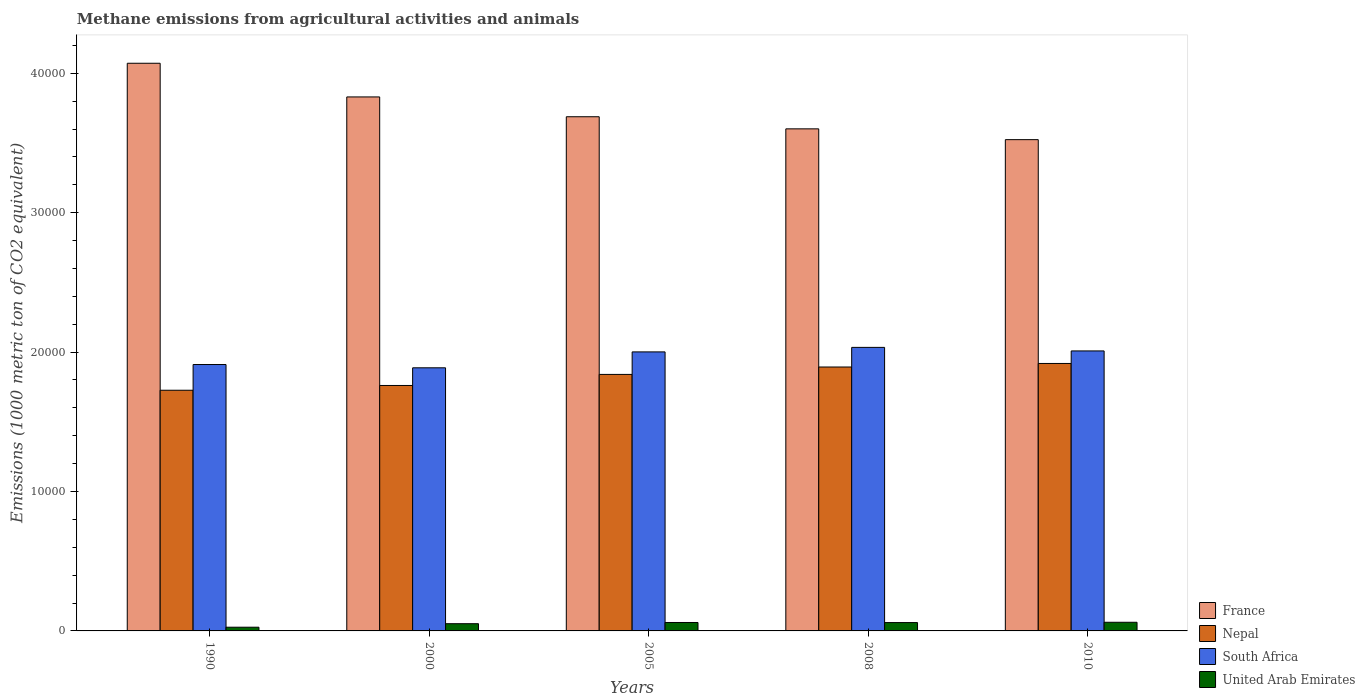How many different coloured bars are there?
Make the answer very short. 4. How many groups of bars are there?
Keep it short and to the point. 5. Are the number of bars per tick equal to the number of legend labels?
Ensure brevity in your answer.  Yes. Are the number of bars on each tick of the X-axis equal?
Provide a short and direct response. Yes. How many bars are there on the 4th tick from the left?
Your answer should be compact. 4. How many bars are there on the 4th tick from the right?
Your response must be concise. 4. What is the label of the 3rd group of bars from the left?
Keep it short and to the point. 2005. What is the amount of methane emitted in South Africa in 2008?
Ensure brevity in your answer.  2.03e+04. Across all years, what is the maximum amount of methane emitted in Nepal?
Make the answer very short. 1.92e+04. Across all years, what is the minimum amount of methane emitted in United Arab Emirates?
Your answer should be very brief. 266.3. In which year was the amount of methane emitted in United Arab Emirates maximum?
Offer a terse response. 2010. In which year was the amount of methane emitted in South Africa minimum?
Provide a succinct answer. 2000. What is the total amount of methane emitted in France in the graph?
Keep it short and to the point. 1.87e+05. What is the difference between the amount of methane emitted in South Africa in 2000 and that in 2010?
Keep it short and to the point. -1210. What is the difference between the amount of methane emitted in Nepal in 2008 and the amount of methane emitted in United Arab Emirates in 2000?
Offer a very short reply. 1.84e+04. What is the average amount of methane emitted in South Africa per year?
Offer a very short reply. 1.97e+04. In the year 2008, what is the difference between the amount of methane emitted in Nepal and amount of methane emitted in United Arab Emirates?
Make the answer very short. 1.83e+04. What is the ratio of the amount of methane emitted in Nepal in 1990 to that in 2000?
Provide a succinct answer. 0.98. What is the difference between the highest and the second highest amount of methane emitted in Nepal?
Make the answer very short. 254.4. What is the difference between the highest and the lowest amount of methane emitted in Nepal?
Provide a succinct answer. 1920.6. In how many years, is the amount of methane emitted in South Africa greater than the average amount of methane emitted in South Africa taken over all years?
Your answer should be very brief. 3. Is it the case that in every year, the sum of the amount of methane emitted in United Arab Emirates and amount of methane emitted in Nepal is greater than the sum of amount of methane emitted in South Africa and amount of methane emitted in France?
Make the answer very short. Yes. What does the 3rd bar from the left in 2005 represents?
Your answer should be compact. South Africa. What does the 3rd bar from the right in 2005 represents?
Offer a terse response. Nepal. Is it the case that in every year, the sum of the amount of methane emitted in United Arab Emirates and amount of methane emitted in South Africa is greater than the amount of methane emitted in Nepal?
Make the answer very short. Yes. How many bars are there?
Your answer should be compact. 20. Are all the bars in the graph horizontal?
Ensure brevity in your answer.  No. What is the difference between two consecutive major ticks on the Y-axis?
Your response must be concise. 10000. Does the graph contain any zero values?
Your answer should be compact. No. Does the graph contain grids?
Ensure brevity in your answer.  No. What is the title of the graph?
Offer a terse response. Methane emissions from agricultural activities and animals. Does "Serbia" appear as one of the legend labels in the graph?
Give a very brief answer. No. What is the label or title of the X-axis?
Ensure brevity in your answer.  Years. What is the label or title of the Y-axis?
Provide a short and direct response. Emissions (1000 metric ton of CO2 equivalent). What is the Emissions (1000 metric ton of CO2 equivalent) in France in 1990?
Make the answer very short. 4.07e+04. What is the Emissions (1000 metric ton of CO2 equivalent) in Nepal in 1990?
Provide a succinct answer. 1.73e+04. What is the Emissions (1000 metric ton of CO2 equivalent) of South Africa in 1990?
Provide a short and direct response. 1.91e+04. What is the Emissions (1000 metric ton of CO2 equivalent) of United Arab Emirates in 1990?
Ensure brevity in your answer.  266.3. What is the Emissions (1000 metric ton of CO2 equivalent) in France in 2000?
Your answer should be very brief. 3.83e+04. What is the Emissions (1000 metric ton of CO2 equivalent) in Nepal in 2000?
Your response must be concise. 1.76e+04. What is the Emissions (1000 metric ton of CO2 equivalent) in South Africa in 2000?
Offer a terse response. 1.89e+04. What is the Emissions (1000 metric ton of CO2 equivalent) in United Arab Emirates in 2000?
Give a very brief answer. 518. What is the Emissions (1000 metric ton of CO2 equivalent) in France in 2005?
Ensure brevity in your answer.  3.69e+04. What is the Emissions (1000 metric ton of CO2 equivalent) of Nepal in 2005?
Your answer should be very brief. 1.84e+04. What is the Emissions (1000 metric ton of CO2 equivalent) of South Africa in 2005?
Give a very brief answer. 2.00e+04. What is the Emissions (1000 metric ton of CO2 equivalent) in United Arab Emirates in 2005?
Make the answer very short. 604.7. What is the Emissions (1000 metric ton of CO2 equivalent) of France in 2008?
Ensure brevity in your answer.  3.60e+04. What is the Emissions (1000 metric ton of CO2 equivalent) in Nepal in 2008?
Provide a succinct answer. 1.89e+04. What is the Emissions (1000 metric ton of CO2 equivalent) of South Africa in 2008?
Offer a very short reply. 2.03e+04. What is the Emissions (1000 metric ton of CO2 equivalent) of United Arab Emirates in 2008?
Keep it short and to the point. 599.2. What is the Emissions (1000 metric ton of CO2 equivalent) of France in 2010?
Your answer should be very brief. 3.52e+04. What is the Emissions (1000 metric ton of CO2 equivalent) in Nepal in 2010?
Your answer should be very brief. 1.92e+04. What is the Emissions (1000 metric ton of CO2 equivalent) of South Africa in 2010?
Offer a very short reply. 2.01e+04. What is the Emissions (1000 metric ton of CO2 equivalent) of United Arab Emirates in 2010?
Provide a short and direct response. 620.8. Across all years, what is the maximum Emissions (1000 metric ton of CO2 equivalent) of France?
Offer a very short reply. 4.07e+04. Across all years, what is the maximum Emissions (1000 metric ton of CO2 equivalent) of Nepal?
Make the answer very short. 1.92e+04. Across all years, what is the maximum Emissions (1000 metric ton of CO2 equivalent) of South Africa?
Offer a terse response. 2.03e+04. Across all years, what is the maximum Emissions (1000 metric ton of CO2 equivalent) of United Arab Emirates?
Offer a terse response. 620.8. Across all years, what is the minimum Emissions (1000 metric ton of CO2 equivalent) of France?
Your answer should be very brief. 3.52e+04. Across all years, what is the minimum Emissions (1000 metric ton of CO2 equivalent) in Nepal?
Offer a terse response. 1.73e+04. Across all years, what is the minimum Emissions (1000 metric ton of CO2 equivalent) of South Africa?
Offer a terse response. 1.89e+04. Across all years, what is the minimum Emissions (1000 metric ton of CO2 equivalent) of United Arab Emirates?
Provide a short and direct response. 266.3. What is the total Emissions (1000 metric ton of CO2 equivalent) in France in the graph?
Your answer should be very brief. 1.87e+05. What is the total Emissions (1000 metric ton of CO2 equivalent) of Nepal in the graph?
Give a very brief answer. 9.14e+04. What is the total Emissions (1000 metric ton of CO2 equivalent) in South Africa in the graph?
Ensure brevity in your answer.  9.84e+04. What is the total Emissions (1000 metric ton of CO2 equivalent) in United Arab Emirates in the graph?
Keep it short and to the point. 2609. What is the difference between the Emissions (1000 metric ton of CO2 equivalent) in France in 1990 and that in 2000?
Your answer should be very brief. 2415.3. What is the difference between the Emissions (1000 metric ton of CO2 equivalent) of Nepal in 1990 and that in 2000?
Provide a short and direct response. -341.8. What is the difference between the Emissions (1000 metric ton of CO2 equivalent) in South Africa in 1990 and that in 2000?
Give a very brief answer. 234.6. What is the difference between the Emissions (1000 metric ton of CO2 equivalent) in United Arab Emirates in 1990 and that in 2000?
Make the answer very short. -251.7. What is the difference between the Emissions (1000 metric ton of CO2 equivalent) of France in 1990 and that in 2005?
Your answer should be compact. 3836.5. What is the difference between the Emissions (1000 metric ton of CO2 equivalent) in Nepal in 1990 and that in 2005?
Offer a terse response. -1135.1. What is the difference between the Emissions (1000 metric ton of CO2 equivalent) in South Africa in 1990 and that in 2005?
Your answer should be very brief. -906.3. What is the difference between the Emissions (1000 metric ton of CO2 equivalent) in United Arab Emirates in 1990 and that in 2005?
Your answer should be compact. -338.4. What is the difference between the Emissions (1000 metric ton of CO2 equivalent) of France in 1990 and that in 2008?
Your response must be concise. 4704.7. What is the difference between the Emissions (1000 metric ton of CO2 equivalent) in Nepal in 1990 and that in 2008?
Your response must be concise. -1666.2. What is the difference between the Emissions (1000 metric ton of CO2 equivalent) of South Africa in 1990 and that in 2008?
Offer a terse response. -1229.7. What is the difference between the Emissions (1000 metric ton of CO2 equivalent) of United Arab Emirates in 1990 and that in 2008?
Ensure brevity in your answer.  -332.9. What is the difference between the Emissions (1000 metric ton of CO2 equivalent) of France in 1990 and that in 2010?
Your answer should be very brief. 5479. What is the difference between the Emissions (1000 metric ton of CO2 equivalent) in Nepal in 1990 and that in 2010?
Your response must be concise. -1920.6. What is the difference between the Emissions (1000 metric ton of CO2 equivalent) in South Africa in 1990 and that in 2010?
Give a very brief answer. -975.4. What is the difference between the Emissions (1000 metric ton of CO2 equivalent) of United Arab Emirates in 1990 and that in 2010?
Provide a short and direct response. -354.5. What is the difference between the Emissions (1000 metric ton of CO2 equivalent) in France in 2000 and that in 2005?
Offer a terse response. 1421.2. What is the difference between the Emissions (1000 metric ton of CO2 equivalent) of Nepal in 2000 and that in 2005?
Make the answer very short. -793.3. What is the difference between the Emissions (1000 metric ton of CO2 equivalent) of South Africa in 2000 and that in 2005?
Provide a short and direct response. -1140.9. What is the difference between the Emissions (1000 metric ton of CO2 equivalent) of United Arab Emirates in 2000 and that in 2005?
Offer a terse response. -86.7. What is the difference between the Emissions (1000 metric ton of CO2 equivalent) of France in 2000 and that in 2008?
Give a very brief answer. 2289.4. What is the difference between the Emissions (1000 metric ton of CO2 equivalent) in Nepal in 2000 and that in 2008?
Ensure brevity in your answer.  -1324.4. What is the difference between the Emissions (1000 metric ton of CO2 equivalent) of South Africa in 2000 and that in 2008?
Keep it short and to the point. -1464.3. What is the difference between the Emissions (1000 metric ton of CO2 equivalent) of United Arab Emirates in 2000 and that in 2008?
Make the answer very short. -81.2. What is the difference between the Emissions (1000 metric ton of CO2 equivalent) in France in 2000 and that in 2010?
Your response must be concise. 3063.7. What is the difference between the Emissions (1000 metric ton of CO2 equivalent) of Nepal in 2000 and that in 2010?
Provide a succinct answer. -1578.8. What is the difference between the Emissions (1000 metric ton of CO2 equivalent) in South Africa in 2000 and that in 2010?
Your answer should be compact. -1210. What is the difference between the Emissions (1000 metric ton of CO2 equivalent) of United Arab Emirates in 2000 and that in 2010?
Give a very brief answer. -102.8. What is the difference between the Emissions (1000 metric ton of CO2 equivalent) in France in 2005 and that in 2008?
Offer a terse response. 868.2. What is the difference between the Emissions (1000 metric ton of CO2 equivalent) in Nepal in 2005 and that in 2008?
Your answer should be compact. -531.1. What is the difference between the Emissions (1000 metric ton of CO2 equivalent) in South Africa in 2005 and that in 2008?
Your answer should be compact. -323.4. What is the difference between the Emissions (1000 metric ton of CO2 equivalent) of France in 2005 and that in 2010?
Give a very brief answer. 1642.5. What is the difference between the Emissions (1000 metric ton of CO2 equivalent) of Nepal in 2005 and that in 2010?
Your answer should be very brief. -785.5. What is the difference between the Emissions (1000 metric ton of CO2 equivalent) of South Africa in 2005 and that in 2010?
Make the answer very short. -69.1. What is the difference between the Emissions (1000 metric ton of CO2 equivalent) of United Arab Emirates in 2005 and that in 2010?
Keep it short and to the point. -16.1. What is the difference between the Emissions (1000 metric ton of CO2 equivalent) of France in 2008 and that in 2010?
Your answer should be compact. 774.3. What is the difference between the Emissions (1000 metric ton of CO2 equivalent) in Nepal in 2008 and that in 2010?
Your response must be concise. -254.4. What is the difference between the Emissions (1000 metric ton of CO2 equivalent) in South Africa in 2008 and that in 2010?
Your response must be concise. 254.3. What is the difference between the Emissions (1000 metric ton of CO2 equivalent) in United Arab Emirates in 2008 and that in 2010?
Offer a terse response. -21.6. What is the difference between the Emissions (1000 metric ton of CO2 equivalent) of France in 1990 and the Emissions (1000 metric ton of CO2 equivalent) of Nepal in 2000?
Provide a short and direct response. 2.31e+04. What is the difference between the Emissions (1000 metric ton of CO2 equivalent) in France in 1990 and the Emissions (1000 metric ton of CO2 equivalent) in South Africa in 2000?
Your answer should be compact. 2.18e+04. What is the difference between the Emissions (1000 metric ton of CO2 equivalent) in France in 1990 and the Emissions (1000 metric ton of CO2 equivalent) in United Arab Emirates in 2000?
Offer a very short reply. 4.02e+04. What is the difference between the Emissions (1000 metric ton of CO2 equivalent) of Nepal in 1990 and the Emissions (1000 metric ton of CO2 equivalent) of South Africa in 2000?
Keep it short and to the point. -1609.4. What is the difference between the Emissions (1000 metric ton of CO2 equivalent) of Nepal in 1990 and the Emissions (1000 metric ton of CO2 equivalent) of United Arab Emirates in 2000?
Offer a terse response. 1.67e+04. What is the difference between the Emissions (1000 metric ton of CO2 equivalent) in South Africa in 1990 and the Emissions (1000 metric ton of CO2 equivalent) in United Arab Emirates in 2000?
Your response must be concise. 1.86e+04. What is the difference between the Emissions (1000 metric ton of CO2 equivalent) of France in 1990 and the Emissions (1000 metric ton of CO2 equivalent) of Nepal in 2005?
Your response must be concise. 2.23e+04. What is the difference between the Emissions (1000 metric ton of CO2 equivalent) of France in 1990 and the Emissions (1000 metric ton of CO2 equivalent) of South Africa in 2005?
Offer a very short reply. 2.07e+04. What is the difference between the Emissions (1000 metric ton of CO2 equivalent) in France in 1990 and the Emissions (1000 metric ton of CO2 equivalent) in United Arab Emirates in 2005?
Your answer should be very brief. 4.01e+04. What is the difference between the Emissions (1000 metric ton of CO2 equivalent) in Nepal in 1990 and the Emissions (1000 metric ton of CO2 equivalent) in South Africa in 2005?
Keep it short and to the point. -2750.3. What is the difference between the Emissions (1000 metric ton of CO2 equivalent) in Nepal in 1990 and the Emissions (1000 metric ton of CO2 equivalent) in United Arab Emirates in 2005?
Ensure brevity in your answer.  1.67e+04. What is the difference between the Emissions (1000 metric ton of CO2 equivalent) of South Africa in 1990 and the Emissions (1000 metric ton of CO2 equivalent) of United Arab Emirates in 2005?
Keep it short and to the point. 1.85e+04. What is the difference between the Emissions (1000 metric ton of CO2 equivalent) of France in 1990 and the Emissions (1000 metric ton of CO2 equivalent) of Nepal in 2008?
Provide a succinct answer. 2.18e+04. What is the difference between the Emissions (1000 metric ton of CO2 equivalent) in France in 1990 and the Emissions (1000 metric ton of CO2 equivalent) in South Africa in 2008?
Ensure brevity in your answer.  2.04e+04. What is the difference between the Emissions (1000 metric ton of CO2 equivalent) of France in 1990 and the Emissions (1000 metric ton of CO2 equivalent) of United Arab Emirates in 2008?
Make the answer very short. 4.01e+04. What is the difference between the Emissions (1000 metric ton of CO2 equivalent) in Nepal in 1990 and the Emissions (1000 metric ton of CO2 equivalent) in South Africa in 2008?
Your answer should be compact. -3073.7. What is the difference between the Emissions (1000 metric ton of CO2 equivalent) in Nepal in 1990 and the Emissions (1000 metric ton of CO2 equivalent) in United Arab Emirates in 2008?
Ensure brevity in your answer.  1.67e+04. What is the difference between the Emissions (1000 metric ton of CO2 equivalent) of South Africa in 1990 and the Emissions (1000 metric ton of CO2 equivalent) of United Arab Emirates in 2008?
Ensure brevity in your answer.  1.85e+04. What is the difference between the Emissions (1000 metric ton of CO2 equivalent) of France in 1990 and the Emissions (1000 metric ton of CO2 equivalent) of Nepal in 2010?
Make the answer very short. 2.15e+04. What is the difference between the Emissions (1000 metric ton of CO2 equivalent) of France in 1990 and the Emissions (1000 metric ton of CO2 equivalent) of South Africa in 2010?
Provide a short and direct response. 2.06e+04. What is the difference between the Emissions (1000 metric ton of CO2 equivalent) in France in 1990 and the Emissions (1000 metric ton of CO2 equivalent) in United Arab Emirates in 2010?
Provide a short and direct response. 4.01e+04. What is the difference between the Emissions (1000 metric ton of CO2 equivalent) in Nepal in 1990 and the Emissions (1000 metric ton of CO2 equivalent) in South Africa in 2010?
Give a very brief answer. -2819.4. What is the difference between the Emissions (1000 metric ton of CO2 equivalent) of Nepal in 1990 and the Emissions (1000 metric ton of CO2 equivalent) of United Arab Emirates in 2010?
Offer a very short reply. 1.66e+04. What is the difference between the Emissions (1000 metric ton of CO2 equivalent) of South Africa in 1990 and the Emissions (1000 metric ton of CO2 equivalent) of United Arab Emirates in 2010?
Keep it short and to the point. 1.85e+04. What is the difference between the Emissions (1000 metric ton of CO2 equivalent) in France in 2000 and the Emissions (1000 metric ton of CO2 equivalent) in Nepal in 2005?
Your answer should be compact. 1.99e+04. What is the difference between the Emissions (1000 metric ton of CO2 equivalent) of France in 2000 and the Emissions (1000 metric ton of CO2 equivalent) of South Africa in 2005?
Your answer should be compact. 1.83e+04. What is the difference between the Emissions (1000 metric ton of CO2 equivalent) in France in 2000 and the Emissions (1000 metric ton of CO2 equivalent) in United Arab Emirates in 2005?
Make the answer very short. 3.77e+04. What is the difference between the Emissions (1000 metric ton of CO2 equivalent) of Nepal in 2000 and the Emissions (1000 metric ton of CO2 equivalent) of South Africa in 2005?
Provide a succinct answer. -2408.5. What is the difference between the Emissions (1000 metric ton of CO2 equivalent) of Nepal in 2000 and the Emissions (1000 metric ton of CO2 equivalent) of United Arab Emirates in 2005?
Your answer should be very brief. 1.70e+04. What is the difference between the Emissions (1000 metric ton of CO2 equivalent) in South Africa in 2000 and the Emissions (1000 metric ton of CO2 equivalent) in United Arab Emirates in 2005?
Offer a very short reply. 1.83e+04. What is the difference between the Emissions (1000 metric ton of CO2 equivalent) of France in 2000 and the Emissions (1000 metric ton of CO2 equivalent) of Nepal in 2008?
Your answer should be compact. 1.94e+04. What is the difference between the Emissions (1000 metric ton of CO2 equivalent) of France in 2000 and the Emissions (1000 metric ton of CO2 equivalent) of South Africa in 2008?
Provide a short and direct response. 1.80e+04. What is the difference between the Emissions (1000 metric ton of CO2 equivalent) of France in 2000 and the Emissions (1000 metric ton of CO2 equivalent) of United Arab Emirates in 2008?
Provide a short and direct response. 3.77e+04. What is the difference between the Emissions (1000 metric ton of CO2 equivalent) in Nepal in 2000 and the Emissions (1000 metric ton of CO2 equivalent) in South Africa in 2008?
Ensure brevity in your answer.  -2731.9. What is the difference between the Emissions (1000 metric ton of CO2 equivalent) in Nepal in 2000 and the Emissions (1000 metric ton of CO2 equivalent) in United Arab Emirates in 2008?
Give a very brief answer. 1.70e+04. What is the difference between the Emissions (1000 metric ton of CO2 equivalent) in South Africa in 2000 and the Emissions (1000 metric ton of CO2 equivalent) in United Arab Emirates in 2008?
Your answer should be very brief. 1.83e+04. What is the difference between the Emissions (1000 metric ton of CO2 equivalent) of France in 2000 and the Emissions (1000 metric ton of CO2 equivalent) of Nepal in 2010?
Give a very brief answer. 1.91e+04. What is the difference between the Emissions (1000 metric ton of CO2 equivalent) of France in 2000 and the Emissions (1000 metric ton of CO2 equivalent) of South Africa in 2010?
Provide a short and direct response. 1.82e+04. What is the difference between the Emissions (1000 metric ton of CO2 equivalent) in France in 2000 and the Emissions (1000 metric ton of CO2 equivalent) in United Arab Emirates in 2010?
Make the answer very short. 3.77e+04. What is the difference between the Emissions (1000 metric ton of CO2 equivalent) in Nepal in 2000 and the Emissions (1000 metric ton of CO2 equivalent) in South Africa in 2010?
Provide a short and direct response. -2477.6. What is the difference between the Emissions (1000 metric ton of CO2 equivalent) in Nepal in 2000 and the Emissions (1000 metric ton of CO2 equivalent) in United Arab Emirates in 2010?
Offer a terse response. 1.70e+04. What is the difference between the Emissions (1000 metric ton of CO2 equivalent) in South Africa in 2000 and the Emissions (1000 metric ton of CO2 equivalent) in United Arab Emirates in 2010?
Give a very brief answer. 1.83e+04. What is the difference between the Emissions (1000 metric ton of CO2 equivalent) in France in 2005 and the Emissions (1000 metric ton of CO2 equivalent) in Nepal in 2008?
Your answer should be very brief. 1.80e+04. What is the difference between the Emissions (1000 metric ton of CO2 equivalent) in France in 2005 and the Emissions (1000 metric ton of CO2 equivalent) in South Africa in 2008?
Provide a succinct answer. 1.65e+04. What is the difference between the Emissions (1000 metric ton of CO2 equivalent) of France in 2005 and the Emissions (1000 metric ton of CO2 equivalent) of United Arab Emirates in 2008?
Your answer should be compact. 3.63e+04. What is the difference between the Emissions (1000 metric ton of CO2 equivalent) of Nepal in 2005 and the Emissions (1000 metric ton of CO2 equivalent) of South Africa in 2008?
Your answer should be compact. -1938.6. What is the difference between the Emissions (1000 metric ton of CO2 equivalent) in Nepal in 2005 and the Emissions (1000 metric ton of CO2 equivalent) in United Arab Emirates in 2008?
Provide a succinct answer. 1.78e+04. What is the difference between the Emissions (1000 metric ton of CO2 equivalent) in South Africa in 2005 and the Emissions (1000 metric ton of CO2 equivalent) in United Arab Emirates in 2008?
Your answer should be compact. 1.94e+04. What is the difference between the Emissions (1000 metric ton of CO2 equivalent) in France in 2005 and the Emissions (1000 metric ton of CO2 equivalent) in Nepal in 2010?
Keep it short and to the point. 1.77e+04. What is the difference between the Emissions (1000 metric ton of CO2 equivalent) in France in 2005 and the Emissions (1000 metric ton of CO2 equivalent) in South Africa in 2010?
Offer a terse response. 1.68e+04. What is the difference between the Emissions (1000 metric ton of CO2 equivalent) in France in 2005 and the Emissions (1000 metric ton of CO2 equivalent) in United Arab Emirates in 2010?
Ensure brevity in your answer.  3.63e+04. What is the difference between the Emissions (1000 metric ton of CO2 equivalent) of Nepal in 2005 and the Emissions (1000 metric ton of CO2 equivalent) of South Africa in 2010?
Provide a short and direct response. -1684.3. What is the difference between the Emissions (1000 metric ton of CO2 equivalent) of Nepal in 2005 and the Emissions (1000 metric ton of CO2 equivalent) of United Arab Emirates in 2010?
Offer a terse response. 1.78e+04. What is the difference between the Emissions (1000 metric ton of CO2 equivalent) in South Africa in 2005 and the Emissions (1000 metric ton of CO2 equivalent) in United Arab Emirates in 2010?
Make the answer very short. 1.94e+04. What is the difference between the Emissions (1000 metric ton of CO2 equivalent) of France in 2008 and the Emissions (1000 metric ton of CO2 equivalent) of Nepal in 2010?
Ensure brevity in your answer.  1.68e+04. What is the difference between the Emissions (1000 metric ton of CO2 equivalent) in France in 2008 and the Emissions (1000 metric ton of CO2 equivalent) in South Africa in 2010?
Ensure brevity in your answer.  1.59e+04. What is the difference between the Emissions (1000 metric ton of CO2 equivalent) in France in 2008 and the Emissions (1000 metric ton of CO2 equivalent) in United Arab Emirates in 2010?
Ensure brevity in your answer.  3.54e+04. What is the difference between the Emissions (1000 metric ton of CO2 equivalent) of Nepal in 2008 and the Emissions (1000 metric ton of CO2 equivalent) of South Africa in 2010?
Offer a terse response. -1153.2. What is the difference between the Emissions (1000 metric ton of CO2 equivalent) in Nepal in 2008 and the Emissions (1000 metric ton of CO2 equivalent) in United Arab Emirates in 2010?
Offer a terse response. 1.83e+04. What is the difference between the Emissions (1000 metric ton of CO2 equivalent) of South Africa in 2008 and the Emissions (1000 metric ton of CO2 equivalent) of United Arab Emirates in 2010?
Provide a succinct answer. 1.97e+04. What is the average Emissions (1000 metric ton of CO2 equivalent) in France per year?
Keep it short and to the point. 3.74e+04. What is the average Emissions (1000 metric ton of CO2 equivalent) in Nepal per year?
Give a very brief answer. 1.83e+04. What is the average Emissions (1000 metric ton of CO2 equivalent) of South Africa per year?
Provide a succinct answer. 1.97e+04. What is the average Emissions (1000 metric ton of CO2 equivalent) in United Arab Emirates per year?
Provide a short and direct response. 521.8. In the year 1990, what is the difference between the Emissions (1000 metric ton of CO2 equivalent) in France and Emissions (1000 metric ton of CO2 equivalent) in Nepal?
Your response must be concise. 2.35e+04. In the year 1990, what is the difference between the Emissions (1000 metric ton of CO2 equivalent) of France and Emissions (1000 metric ton of CO2 equivalent) of South Africa?
Provide a short and direct response. 2.16e+04. In the year 1990, what is the difference between the Emissions (1000 metric ton of CO2 equivalent) in France and Emissions (1000 metric ton of CO2 equivalent) in United Arab Emirates?
Give a very brief answer. 4.05e+04. In the year 1990, what is the difference between the Emissions (1000 metric ton of CO2 equivalent) in Nepal and Emissions (1000 metric ton of CO2 equivalent) in South Africa?
Give a very brief answer. -1844. In the year 1990, what is the difference between the Emissions (1000 metric ton of CO2 equivalent) of Nepal and Emissions (1000 metric ton of CO2 equivalent) of United Arab Emirates?
Offer a very short reply. 1.70e+04. In the year 1990, what is the difference between the Emissions (1000 metric ton of CO2 equivalent) of South Africa and Emissions (1000 metric ton of CO2 equivalent) of United Arab Emirates?
Give a very brief answer. 1.88e+04. In the year 2000, what is the difference between the Emissions (1000 metric ton of CO2 equivalent) in France and Emissions (1000 metric ton of CO2 equivalent) in Nepal?
Give a very brief answer. 2.07e+04. In the year 2000, what is the difference between the Emissions (1000 metric ton of CO2 equivalent) in France and Emissions (1000 metric ton of CO2 equivalent) in South Africa?
Give a very brief answer. 1.94e+04. In the year 2000, what is the difference between the Emissions (1000 metric ton of CO2 equivalent) in France and Emissions (1000 metric ton of CO2 equivalent) in United Arab Emirates?
Provide a succinct answer. 3.78e+04. In the year 2000, what is the difference between the Emissions (1000 metric ton of CO2 equivalent) of Nepal and Emissions (1000 metric ton of CO2 equivalent) of South Africa?
Ensure brevity in your answer.  -1267.6. In the year 2000, what is the difference between the Emissions (1000 metric ton of CO2 equivalent) of Nepal and Emissions (1000 metric ton of CO2 equivalent) of United Arab Emirates?
Keep it short and to the point. 1.71e+04. In the year 2000, what is the difference between the Emissions (1000 metric ton of CO2 equivalent) in South Africa and Emissions (1000 metric ton of CO2 equivalent) in United Arab Emirates?
Ensure brevity in your answer.  1.84e+04. In the year 2005, what is the difference between the Emissions (1000 metric ton of CO2 equivalent) in France and Emissions (1000 metric ton of CO2 equivalent) in Nepal?
Provide a short and direct response. 1.85e+04. In the year 2005, what is the difference between the Emissions (1000 metric ton of CO2 equivalent) in France and Emissions (1000 metric ton of CO2 equivalent) in South Africa?
Keep it short and to the point. 1.69e+04. In the year 2005, what is the difference between the Emissions (1000 metric ton of CO2 equivalent) in France and Emissions (1000 metric ton of CO2 equivalent) in United Arab Emirates?
Offer a very short reply. 3.63e+04. In the year 2005, what is the difference between the Emissions (1000 metric ton of CO2 equivalent) in Nepal and Emissions (1000 metric ton of CO2 equivalent) in South Africa?
Provide a short and direct response. -1615.2. In the year 2005, what is the difference between the Emissions (1000 metric ton of CO2 equivalent) in Nepal and Emissions (1000 metric ton of CO2 equivalent) in United Arab Emirates?
Keep it short and to the point. 1.78e+04. In the year 2005, what is the difference between the Emissions (1000 metric ton of CO2 equivalent) in South Africa and Emissions (1000 metric ton of CO2 equivalent) in United Arab Emirates?
Your answer should be very brief. 1.94e+04. In the year 2008, what is the difference between the Emissions (1000 metric ton of CO2 equivalent) in France and Emissions (1000 metric ton of CO2 equivalent) in Nepal?
Your answer should be compact. 1.71e+04. In the year 2008, what is the difference between the Emissions (1000 metric ton of CO2 equivalent) in France and Emissions (1000 metric ton of CO2 equivalent) in South Africa?
Keep it short and to the point. 1.57e+04. In the year 2008, what is the difference between the Emissions (1000 metric ton of CO2 equivalent) of France and Emissions (1000 metric ton of CO2 equivalent) of United Arab Emirates?
Ensure brevity in your answer.  3.54e+04. In the year 2008, what is the difference between the Emissions (1000 metric ton of CO2 equivalent) of Nepal and Emissions (1000 metric ton of CO2 equivalent) of South Africa?
Make the answer very short. -1407.5. In the year 2008, what is the difference between the Emissions (1000 metric ton of CO2 equivalent) in Nepal and Emissions (1000 metric ton of CO2 equivalent) in United Arab Emirates?
Provide a succinct answer. 1.83e+04. In the year 2008, what is the difference between the Emissions (1000 metric ton of CO2 equivalent) of South Africa and Emissions (1000 metric ton of CO2 equivalent) of United Arab Emirates?
Offer a very short reply. 1.97e+04. In the year 2010, what is the difference between the Emissions (1000 metric ton of CO2 equivalent) in France and Emissions (1000 metric ton of CO2 equivalent) in Nepal?
Your answer should be compact. 1.61e+04. In the year 2010, what is the difference between the Emissions (1000 metric ton of CO2 equivalent) in France and Emissions (1000 metric ton of CO2 equivalent) in South Africa?
Keep it short and to the point. 1.52e+04. In the year 2010, what is the difference between the Emissions (1000 metric ton of CO2 equivalent) of France and Emissions (1000 metric ton of CO2 equivalent) of United Arab Emirates?
Your answer should be very brief. 3.46e+04. In the year 2010, what is the difference between the Emissions (1000 metric ton of CO2 equivalent) in Nepal and Emissions (1000 metric ton of CO2 equivalent) in South Africa?
Ensure brevity in your answer.  -898.8. In the year 2010, what is the difference between the Emissions (1000 metric ton of CO2 equivalent) in Nepal and Emissions (1000 metric ton of CO2 equivalent) in United Arab Emirates?
Give a very brief answer. 1.86e+04. In the year 2010, what is the difference between the Emissions (1000 metric ton of CO2 equivalent) in South Africa and Emissions (1000 metric ton of CO2 equivalent) in United Arab Emirates?
Your response must be concise. 1.95e+04. What is the ratio of the Emissions (1000 metric ton of CO2 equivalent) of France in 1990 to that in 2000?
Your response must be concise. 1.06. What is the ratio of the Emissions (1000 metric ton of CO2 equivalent) in Nepal in 1990 to that in 2000?
Your answer should be very brief. 0.98. What is the ratio of the Emissions (1000 metric ton of CO2 equivalent) of South Africa in 1990 to that in 2000?
Offer a terse response. 1.01. What is the ratio of the Emissions (1000 metric ton of CO2 equivalent) in United Arab Emirates in 1990 to that in 2000?
Provide a succinct answer. 0.51. What is the ratio of the Emissions (1000 metric ton of CO2 equivalent) in France in 1990 to that in 2005?
Provide a short and direct response. 1.1. What is the ratio of the Emissions (1000 metric ton of CO2 equivalent) of Nepal in 1990 to that in 2005?
Your response must be concise. 0.94. What is the ratio of the Emissions (1000 metric ton of CO2 equivalent) of South Africa in 1990 to that in 2005?
Make the answer very short. 0.95. What is the ratio of the Emissions (1000 metric ton of CO2 equivalent) of United Arab Emirates in 1990 to that in 2005?
Make the answer very short. 0.44. What is the ratio of the Emissions (1000 metric ton of CO2 equivalent) of France in 1990 to that in 2008?
Ensure brevity in your answer.  1.13. What is the ratio of the Emissions (1000 metric ton of CO2 equivalent) in Nepal in 1990 to that in 2008?
Make the answer very short. 0.91. What is the ratio of the Emissions (1000 metric ton of CO2 equivalent) in South Africa in 1990 to that in 2008?
Your response must be concise. 0.94. What is the ratio of the Emissions (1000 metric ton of CO2 equivalent) of United Arab Emirates in 1990 to that in 2008?
Keep it short and to the point. 0.44. What is the ratio of the Emissions (1000 metric ton of CO2 equivalent) of France in 1990 to that in 2010?
Ensure brevity in your answer.  1.16. What is the ratio of the Emissions (1000 metric ton of CO2 equivalent) of Nepal in 1990 to that in 2010?
Keep it short and to the point. 0.9. What is the ratio of the Emissions (1000 metric ton of CO2 equivalent) in South Africa in 1990 to that in 2010?
Give a very brief answer. 0.95. What is the ratio of the Emissions (1000 metric ton of CO2 equivalent) of United Arab Emirates in 1990 to that in 2010?
Offer a terse response. 0.43. What is the ratio of the Emissions (1000 metric ton of CO2 equivalent) of France in 2000 to that in 2005?
Your response must be concise. 1.04. What is the ratio of the Emissions (1000 metric ton of CO2 equivalent) in Nepal in 2000 to that in 2005?
Ensure brevity in your answer.  0.96. What is the ratio of the Emissions (1000 metric ton of CO2 equivalent) of South Africa in 2000 to that in 2005?
Your answer should be very brief. 0.94. What is the ratio of the Emissions (1000 metric ton of CO2 equivalent) in United Arab Emirates in 2000 to that in 2005?
Your response must be concise. 0.86. What is the ratio of the Emissions (1000 metric ton of CO2 equivalent) of France in 2000 to that in 2008?
Ensure brevity in your answer.  1.06. What is the ratio of the Emissions (1000 metric ton of CO2 equivalent) of Nepal in 2000 to that in 2008?
Offer a terse response. 0.93. What is the ratio of the Emissions (1000 metric ton of CO2 equivalent) of South Africa in 2000 to that in 2008?
Your answer should be very brief. 0.93. What is the ratio of the Emissions (1000 metric ton of CO2 equivalent) of United Arab Emirates in 2000 to that in 2008?
Your answer should be compact. 0.86. What is the ratio of the Emissions (1000 metric ton of CO2 equivalent) in France in 2000 to that in 2010?
Your answer should be very brief. 1.09. What is the ratio of the Emissions (1000 metric ton of CO2 equivalent) in Nepal in 2000 to that in 2010?
Provide a succinct answer. 0.92. What is the ratio of the Emissions (1000 metric ton of CO2 equivalent) of South Africa in 2000 to that in 2010?
Make the answer very short. 0.94. What is the ratio of the Emissions (1000 metric ton of CO2 equivalent) in United Arab Emirates in 2000 to that in 2010?
Your response must be concise. 0.83. What is the ratio of the Emissions (1000 metric ton of CO2 equivalent) in France in 2005 to that in 2008?
Offer a terse response. 1.02. What is the ratio of the Emissions (1000 metric ton of CO2 equivalent) in Nepal in 2005 to that in 2008?
Ensure brevity in your answer.  0.97. What is the ratio of the Emissions (1000 metric ton of CO2 equivalent) of South Africa in 2005 to that in 2008?
Keep it short and to the point. 0.98. What is the ratio of the Emissions (1000 metric ton of CO2 equivalent) of United Arab Emirates in 2005 to that in 2008?
Provide a succinct answer. 1.01. What is the ratio of the Emissions (1000 metric ton of CO2 equivalent) in France in 2005 to that in 2010?
Give a very brief answer. 1.05. What is the ratio of the Emissions (1000 metric ton of CO2 equivalent) in Nepal in 2005 to that in 2010?
Make the answer very short. 0.96. What is the ratio of the Emissions (1000 metric ton of CO2 equivalent) in South Africa in 2005 to that in 2010?
Provide a short and direct response. 1. What is the ratio of the Emissions (1000 metric ton of CO2 equivalent) in United Arab Emirates in 2005 to that in 2010?
Provide a succinct answer. 0.97. What is the ratio of the Emissions (1000 metric ton of CO2 equivalent) of France in 2008 to that in 2010?
Provide a short and direct response. 1.02. What is the ratio of the Emissions (1000 metric ton of CO2 equivalent) in Nepal in 2008 to that in 2010?
Your answer should be very brief. 0.99. What is the ratio of the Emissions (1000 metric ton of CO2 equivalent) of South Africa in 2008 to that in 2010?
Provide a short and direct response. 1.01. What is the ratio of the Emissions (1000 metric ton of CO2 equivalent) in United Arab Emirates in 2008 to that in 2010?
Provide a succinct answer. 0.97. What is the difference between the highest and the second highest Emissions (1000 metric ton of CO2 equivalent) of France?
Make the answer very short. 2415.3. What is the difference between the highest and the second highest Emissions (1000 metric ton of CO2 equivalent) of Nepal?
Give a very brief answer. 254.4. What is the difference between the highest and the second highest Emissions (1000 metric ton of CO2 equivalent) of South Africa?
Offer a very short reply. 254.3. What is the difference between the highest and the lowest Emissions (1000 metric ton of CO2 equivalent) in France?
Give a very brief answer. 5479. What is the difference between the highest and the lowest Emissions (1000 metric ton of CO2 equivalent) of Nepal?
Provide a succinct answer. 1920.6. What is the difference between the highest and the lowest Emissions (1000 metric ton of CO2 equivalent) in South Africa?
Offer a very short reply. 1464.3. What is the difference between the highest and the lowest Emissions (1000 metric ton of CO2 equivalent) in United Arab Emirates?
Give a very brief answer. 354.5. 